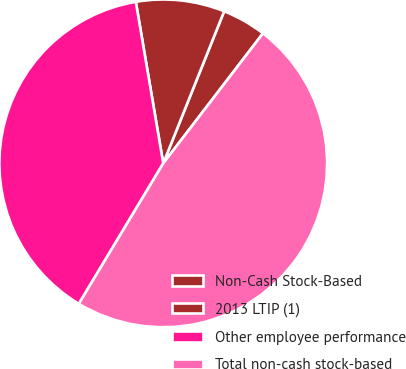Convert chart to OTSL. <chart><loc_0><loc_0><loc_500><loc_500><pie_chart><fcel>Non-Cash Stock-Based<fcel>2013 LTIP (1)<fcel>Other employee performance<fcel>Total non-cash stock-based<nl><fcel>4.35%<fcel>8.74%<fcel>38.71%<fcel>48.2%<nl></chart> 